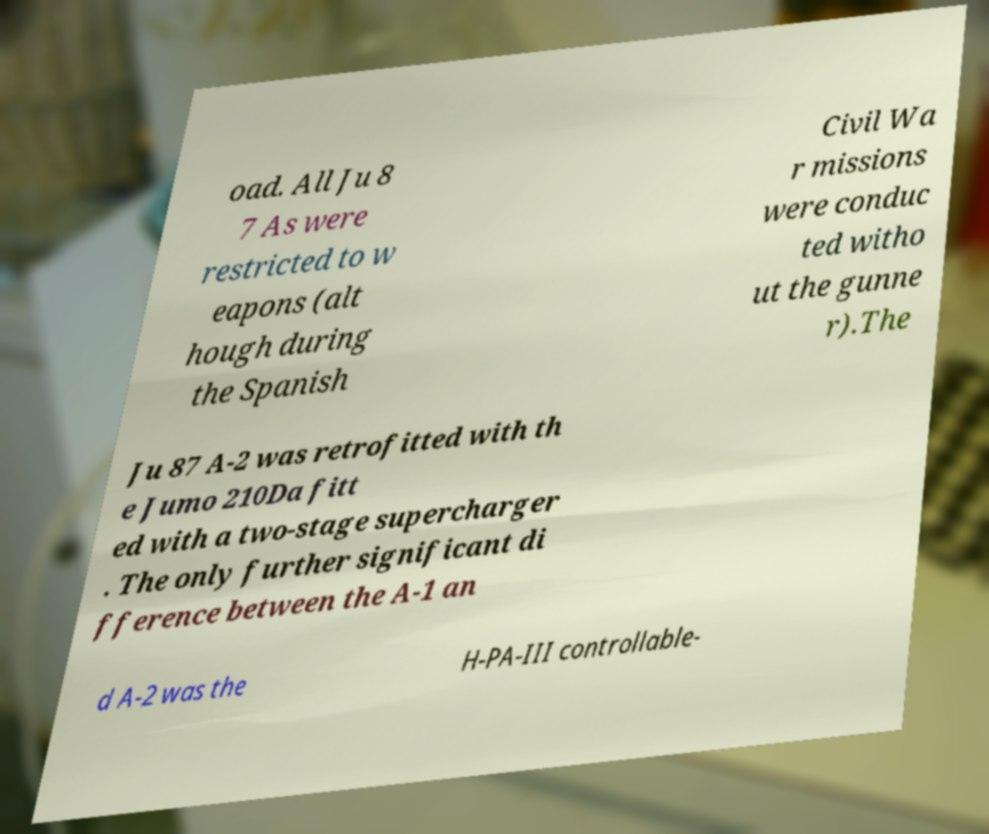What messages or text are displayed in this image? I need them in a readable, typed format. oad. All Ju 8 7 As were restricted to w eapons (alt hough during the Spanish Civil Wa r missions were conduc ted witho ut the gunne r).The Ju 87 A-2 was retrofitted with th e Jumo 210Da fitt ed with a two-stage supercharger . The only further significant di fference between the A-1 an d A-2 was the H-PA-III controllable- 